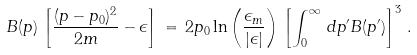Convert formula to latex. <formula><loc_0><loc_0><loc_500><loc_500>B ( { p } ) \, \left [ \frac { ( p - p _ { 0 } ) ^ { 2 } } { 2 m } - \epsilon \right ] \, = \, 2 p _ { 0 } \ln \left ( \frac { \epsilon _ { m } } { | \epsilon | } \right ) \, \left [ \int _ { 0 } ^ { \infty } \, d p ^ { \prime } B ( p ^ { \prime } ) \right ] ^ { 3 } \, .</formula> 